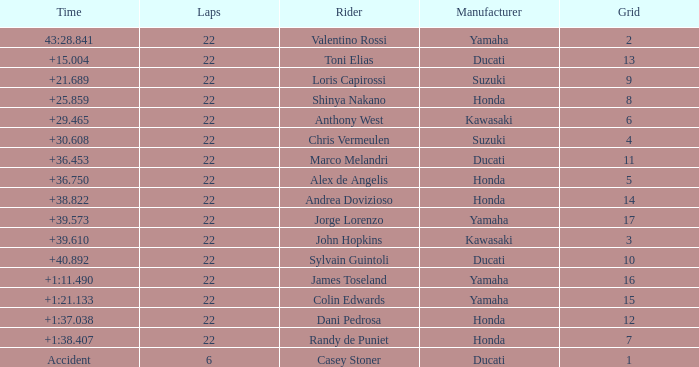What is Honda's highest grid with a time of +1:38.407? 7.0. 